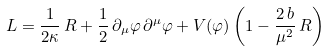<formula> <loc_0><loc_0><loc_500><loc_500>L = \frac { 1 } { 2 \kappa } \, R + \frac { 1 } { 2 } \, \partial _ { \mu } \varphi \, \partial ^ { \mu } \varphi + V ( \varphi ) \left ( 1 - \frac { 2 \, b } { \mu ^ { 2 } } \, R \right )</formula> 